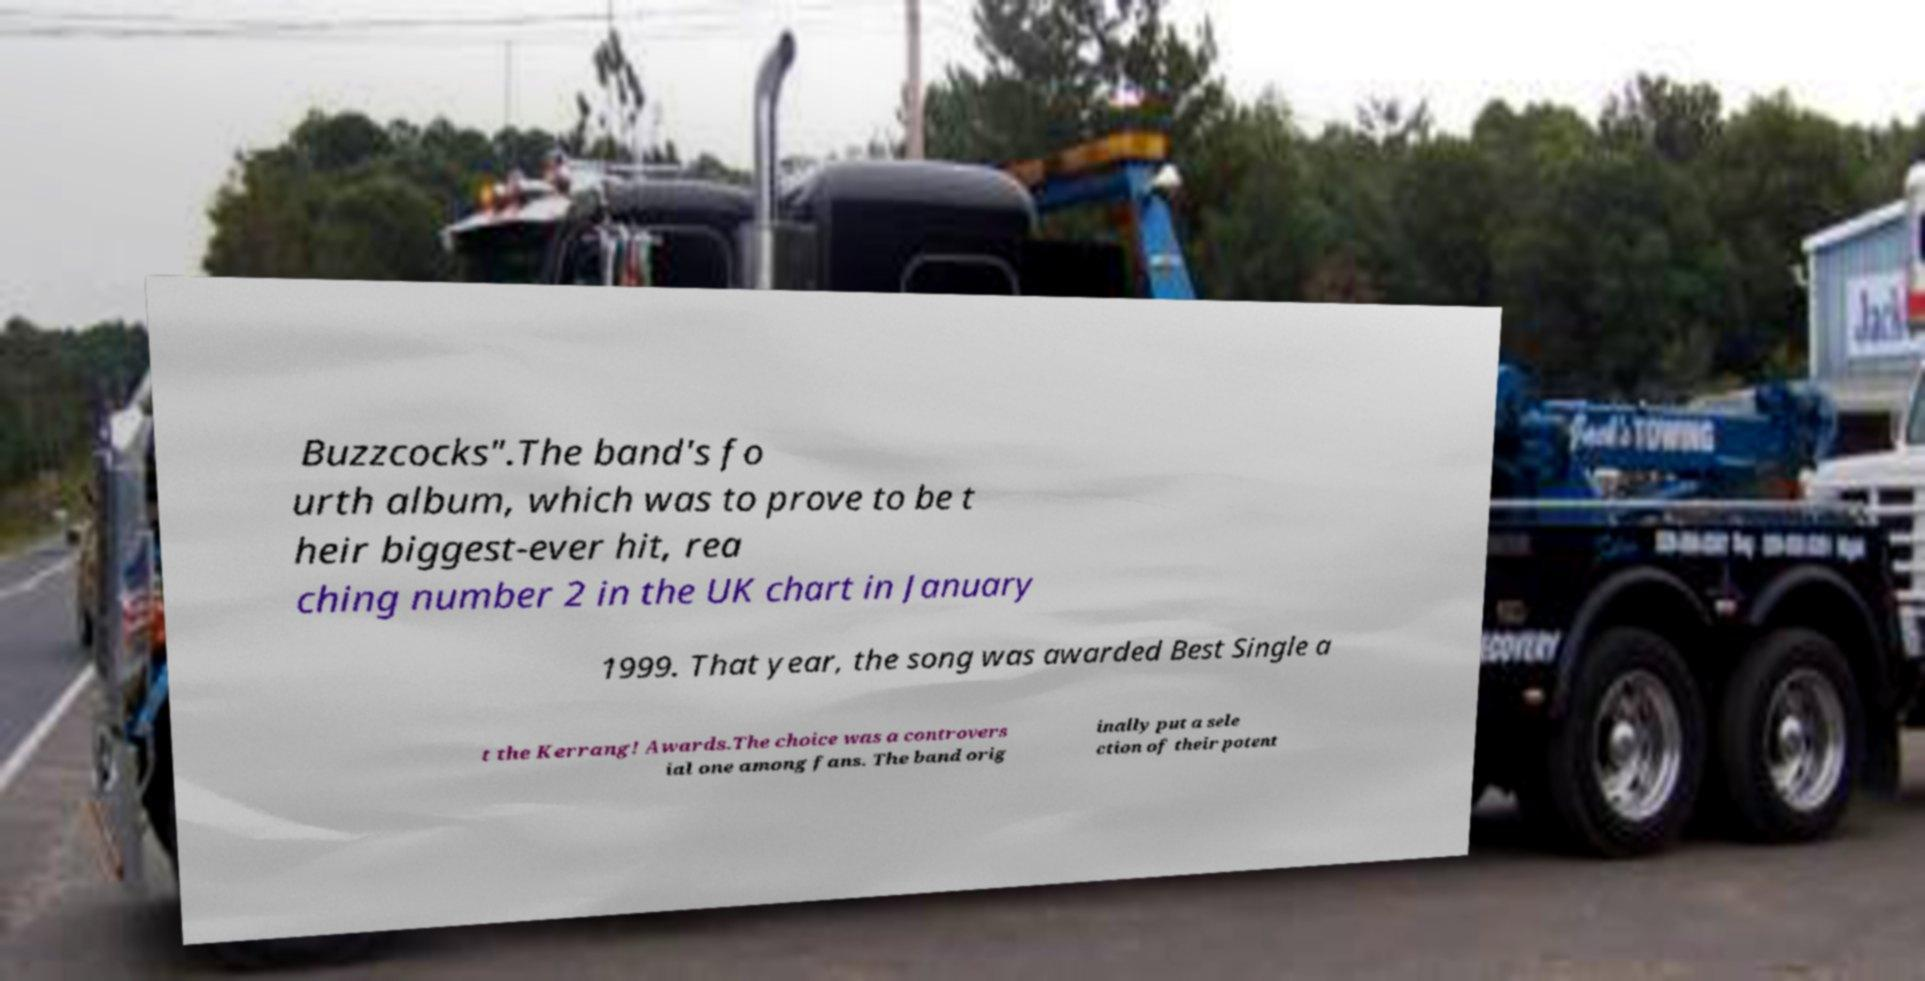Please identify and transcribe the text found in this image. Buzzcocks".The band's fo urth album, which was to prove to be t heir biggest-ever hit, rea ching number 2 in the UK chart in January 1999. That year, the song was awarded Best Single a t the Kerrang! Awards.The choice was a controvers ial one among fans. The band orig inally put a sele ction of their potent 